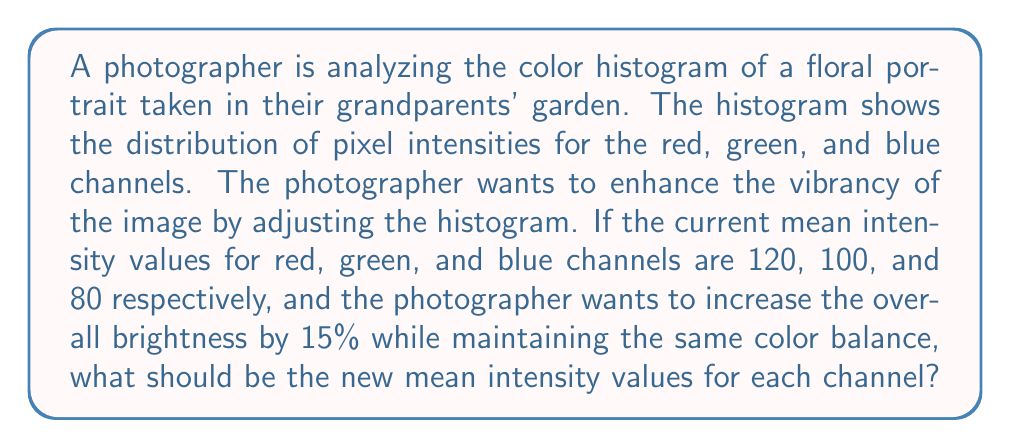Solve this math problem. To solve this problem, we need to follow these steps:

1. Calculate the current overall mean intensity:
   $$\text{Current Mean} = \frac{R + G + B}{3} = \frac{120 + 100 + 80}{3} = 100$$

2. Calculate the new overall mean intensity with 15% increase:
   $$\text{New Mean} = \text{Current Mean} \times 1.15 = 100 \times 1.15 = 115$$

3. Calculate the scaling factor to maintain color balance:
   $$\text{Scaling Factor} = \frac{\text{New Mean}}{\text{Current Mean}} = \frac{115}{100} = 1.15$$

4. Apply the scaling factor to each channel:
   
   Red: $$R_{new} = R_{current} \times \text{Scaling Factor} = 120 \times 1.15 = 138$$
   
   Green: $$G_{new} = G_{current} \times \text{Scaling Factor} = 100 \times 1.15 = 115$$
   
   Blue: $$B_{new} = B_{current} \times \text{Scaling Factor} = 80 \times 1.15 = 92$$

Therefore, the new mean intensity values for each channel should be 138 for red, 115 for green, and 92 for blue.
Answer: Red: 138, Green: 115, Blue: 92 